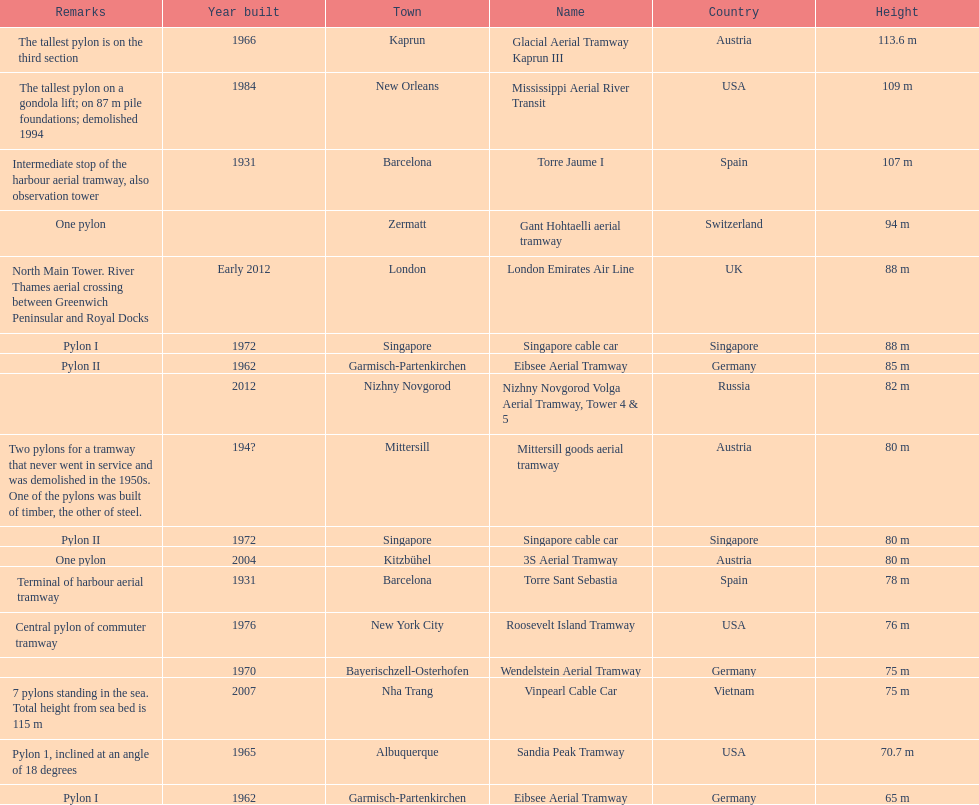List two pylons that are at most, 80 m in height. Mittersill goods aerial tramway, Singapore cable car. 